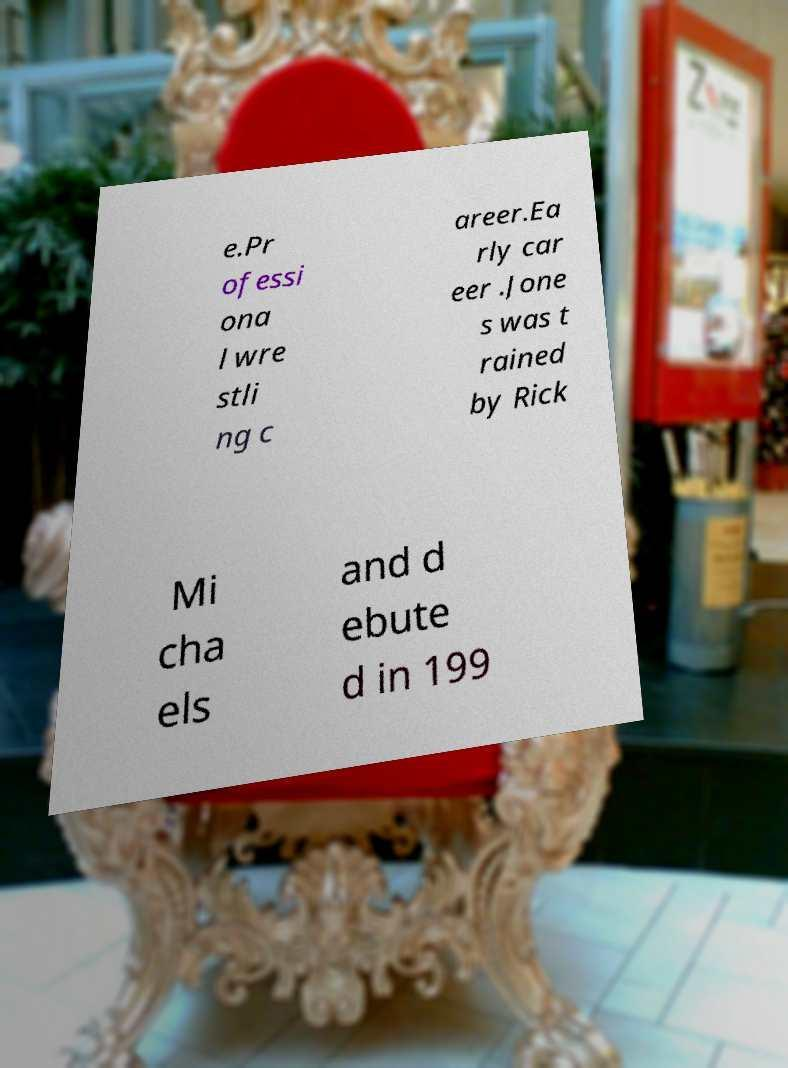Could you extract and type out the text from this image? e.Pr ofessi ona l wre stli ng c areer.Ea rly car eer .Jone s was t rained by Rick Mi cha els and d ebute d in 199 